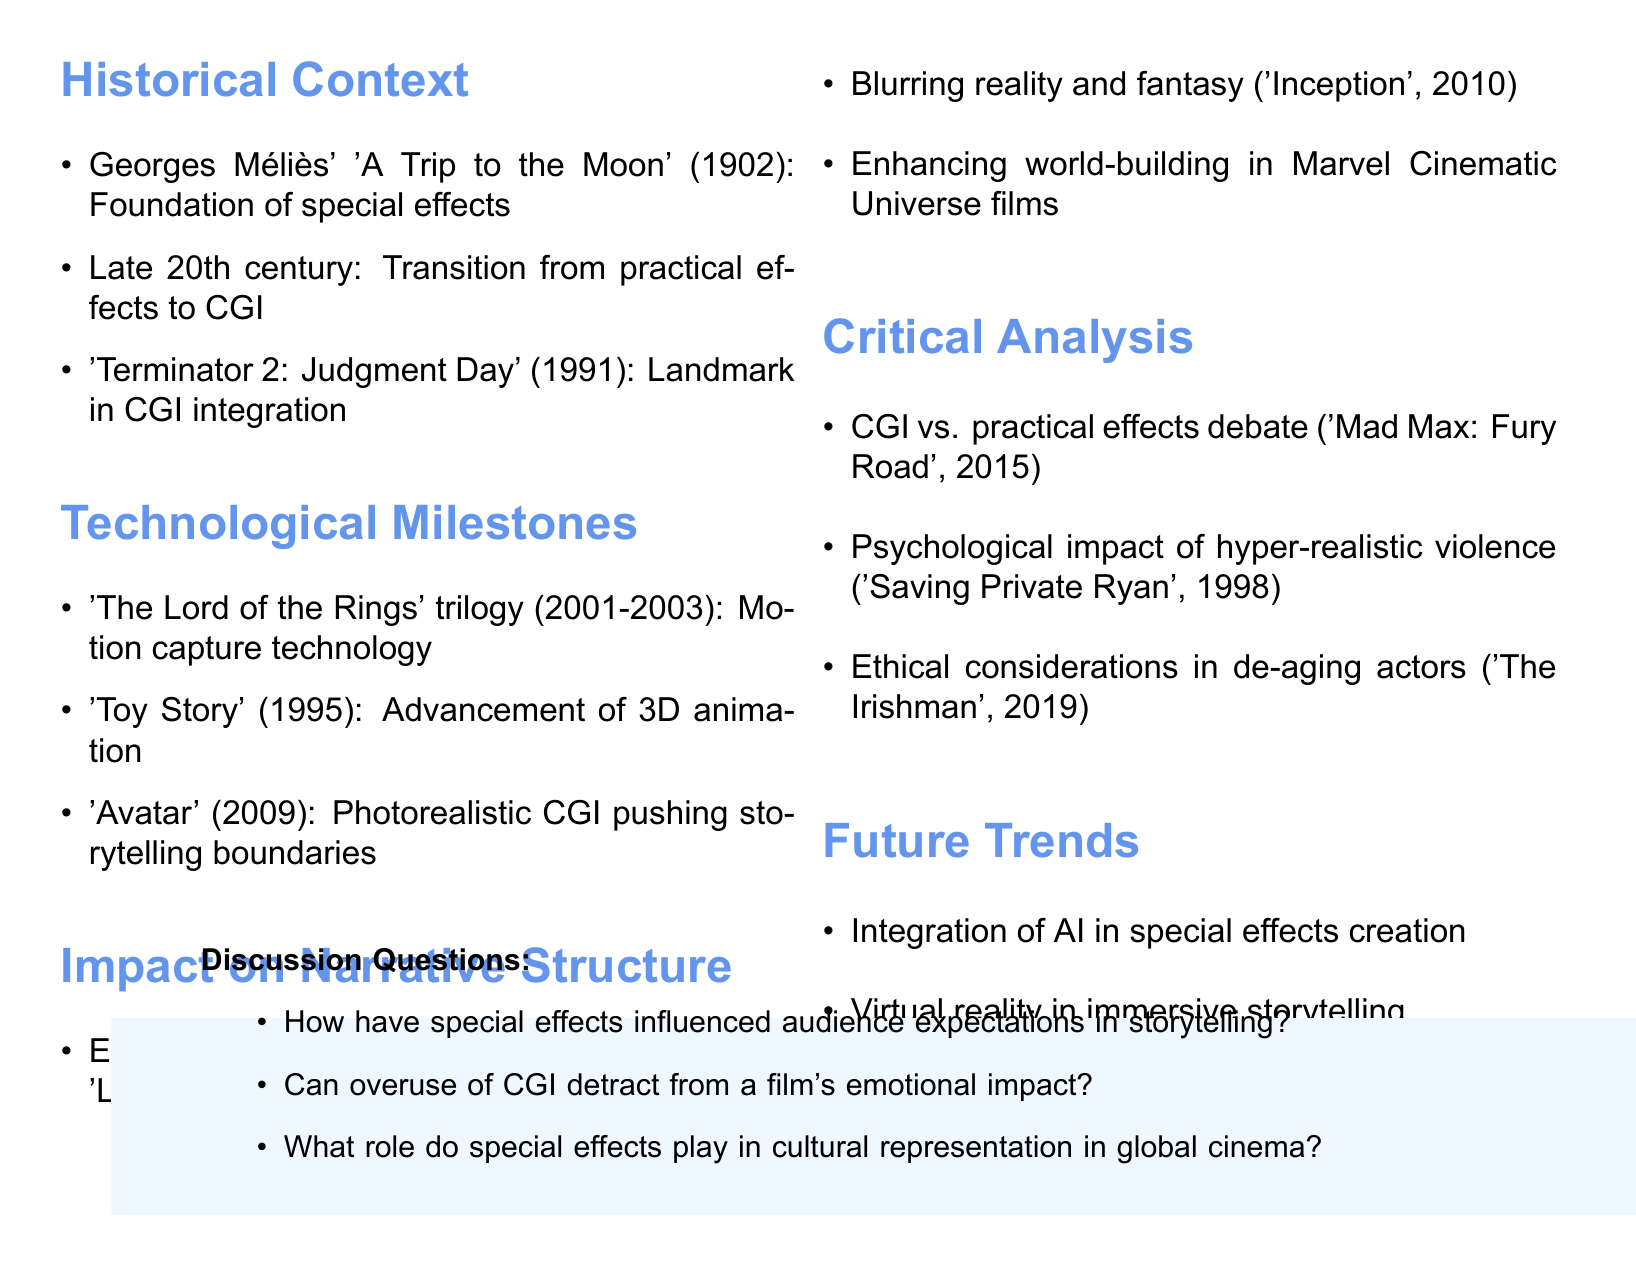What landmark film integrated CGI in 1991? According to the document, 'Terminator 2: Judgment Day' (1991) is mentioned as a landmark in CGI integration.
Answer: 'Terminator 2: Judgment Day' Which technology was introduced in 'The Lord of the Rings' trilogy? The document notes that motion capture technology was introduced in 'The Lord of the Rings' trilogy (2001-2003).
Answer: Motion capture technology What film is cited as enabling previously 'unfilmable' stories? The notes indicate 'Life of Pi' (2012) as an example of enabling previously 'unfilmable' stories.
Answer: 'Life of Pi' What is a debate raised in the critical analysis section? The document discusses a debate on the overreliance on CGI versus practical effects, with 'Mad Max: Fury Road' (2015) as a relevant example.
Answer: Overreliance on CGI vs. practical effects What year was 'Avatar' released? The document states that 'Avatar' was released in 2009, highlighting its photorealistic CGI.
Answer: 2009 What future trend relates to storytelling technology? The document mentions the integration of AI in special effects creation as a future trend relevant to storytelling technology.
Answer: Integration of AI What psychological effect is discussed in relation to violence in films? The document addresses the psychological impact of hyper-realistic violence, exemplified by 'Saving Private Ryan' (1998).
Answer: Hyper-realistic violence How many discussion questions are listed in the document? There are three discussion questions listed in the notes about special effects and storytelling.
Answer: Three 